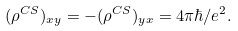<formula> <loc_0><loc_0><loc_500><loc_500>( \rho ^ { C S } ) _ { x y } = - ( \rho ^ { C S } ) _ { y x } = 4 \pi \hbar { / } e ^ { 2 } .</formula> 